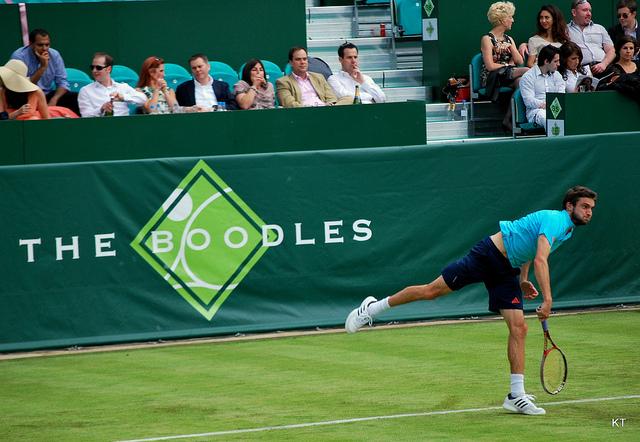What is the event here?
Give a very brief answer. Tennis. Has the man hit the ball yet?
Be succinct. Yes. What is the speed of the serve?
Write a very short answer. Fast. How many feet is the man standing on?
Answer briefly. 1. What geometric shape is on the fence banner?
Keep it brief. Diamond. What sport is this?
Write a very short answer. Tennis. What language are on the walls?
Short answer required. English. 